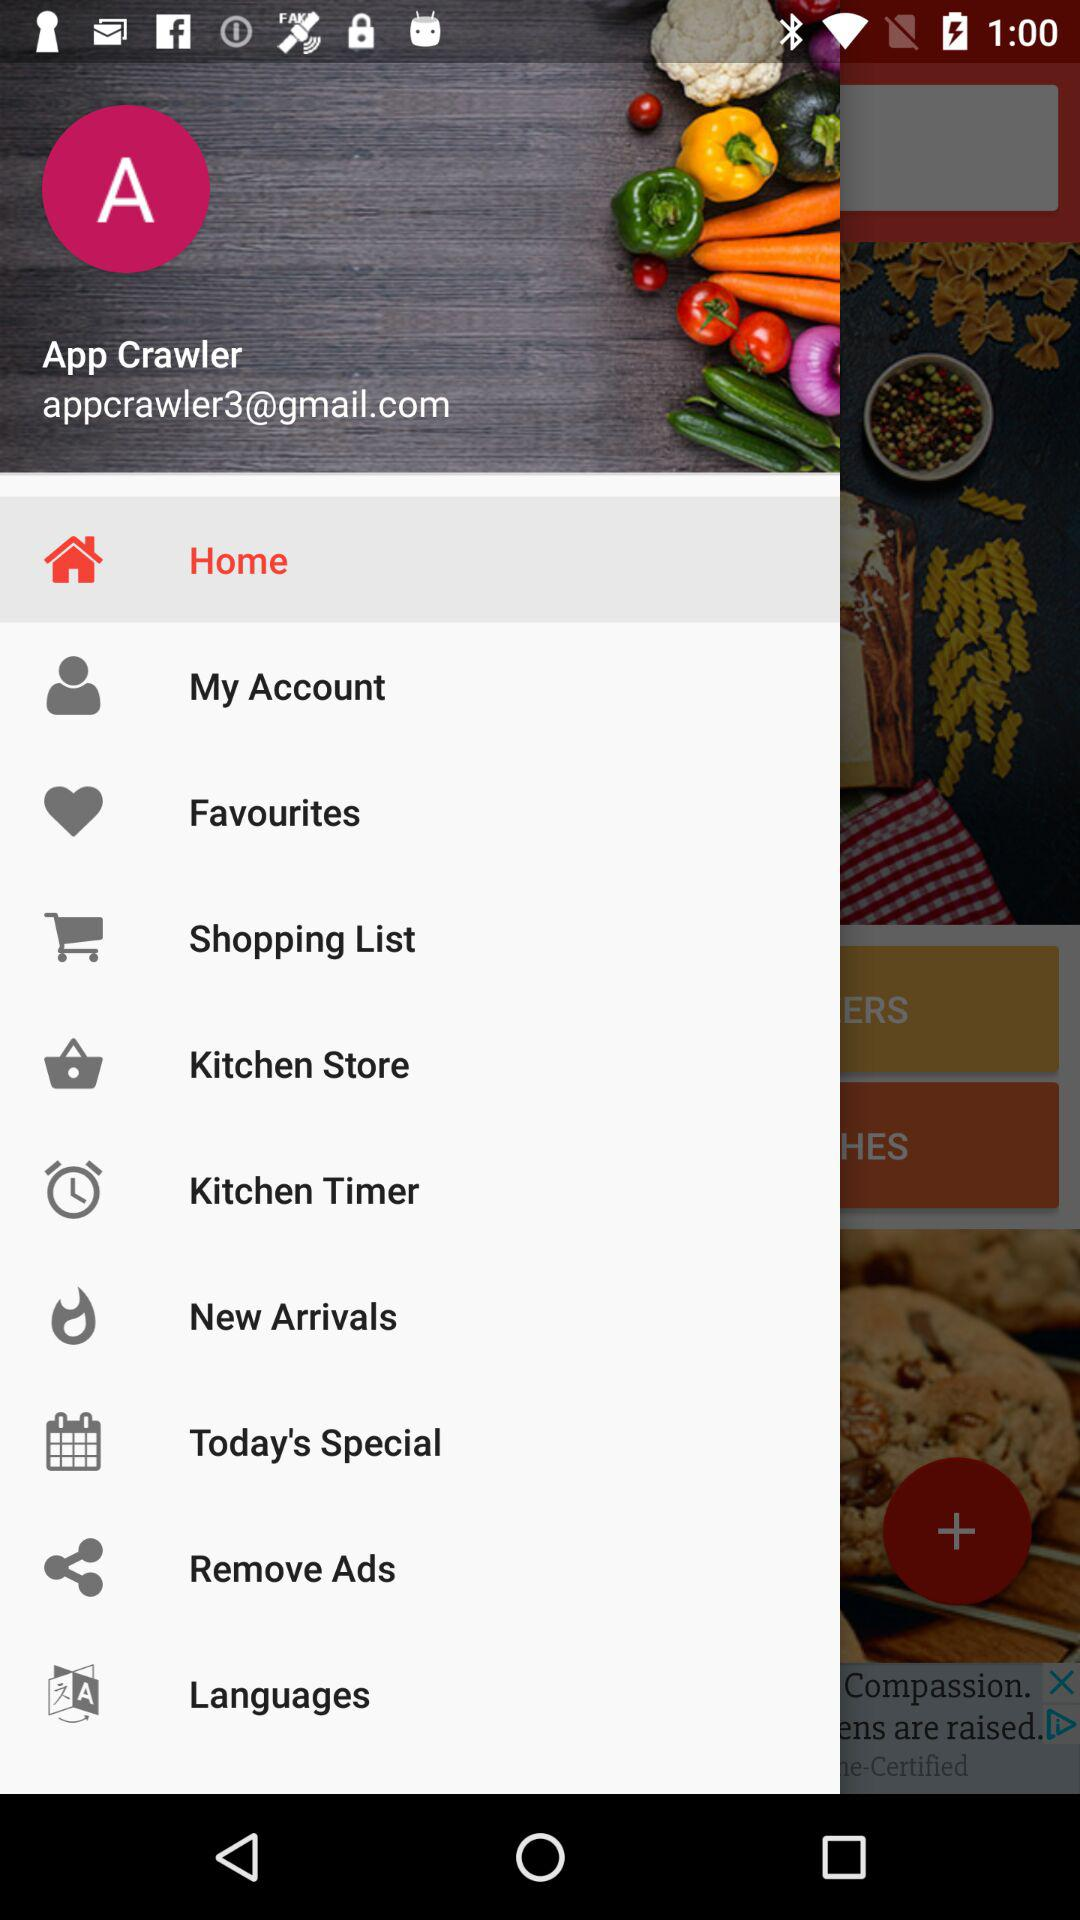Which is the selected option? The selected option is "Home". 